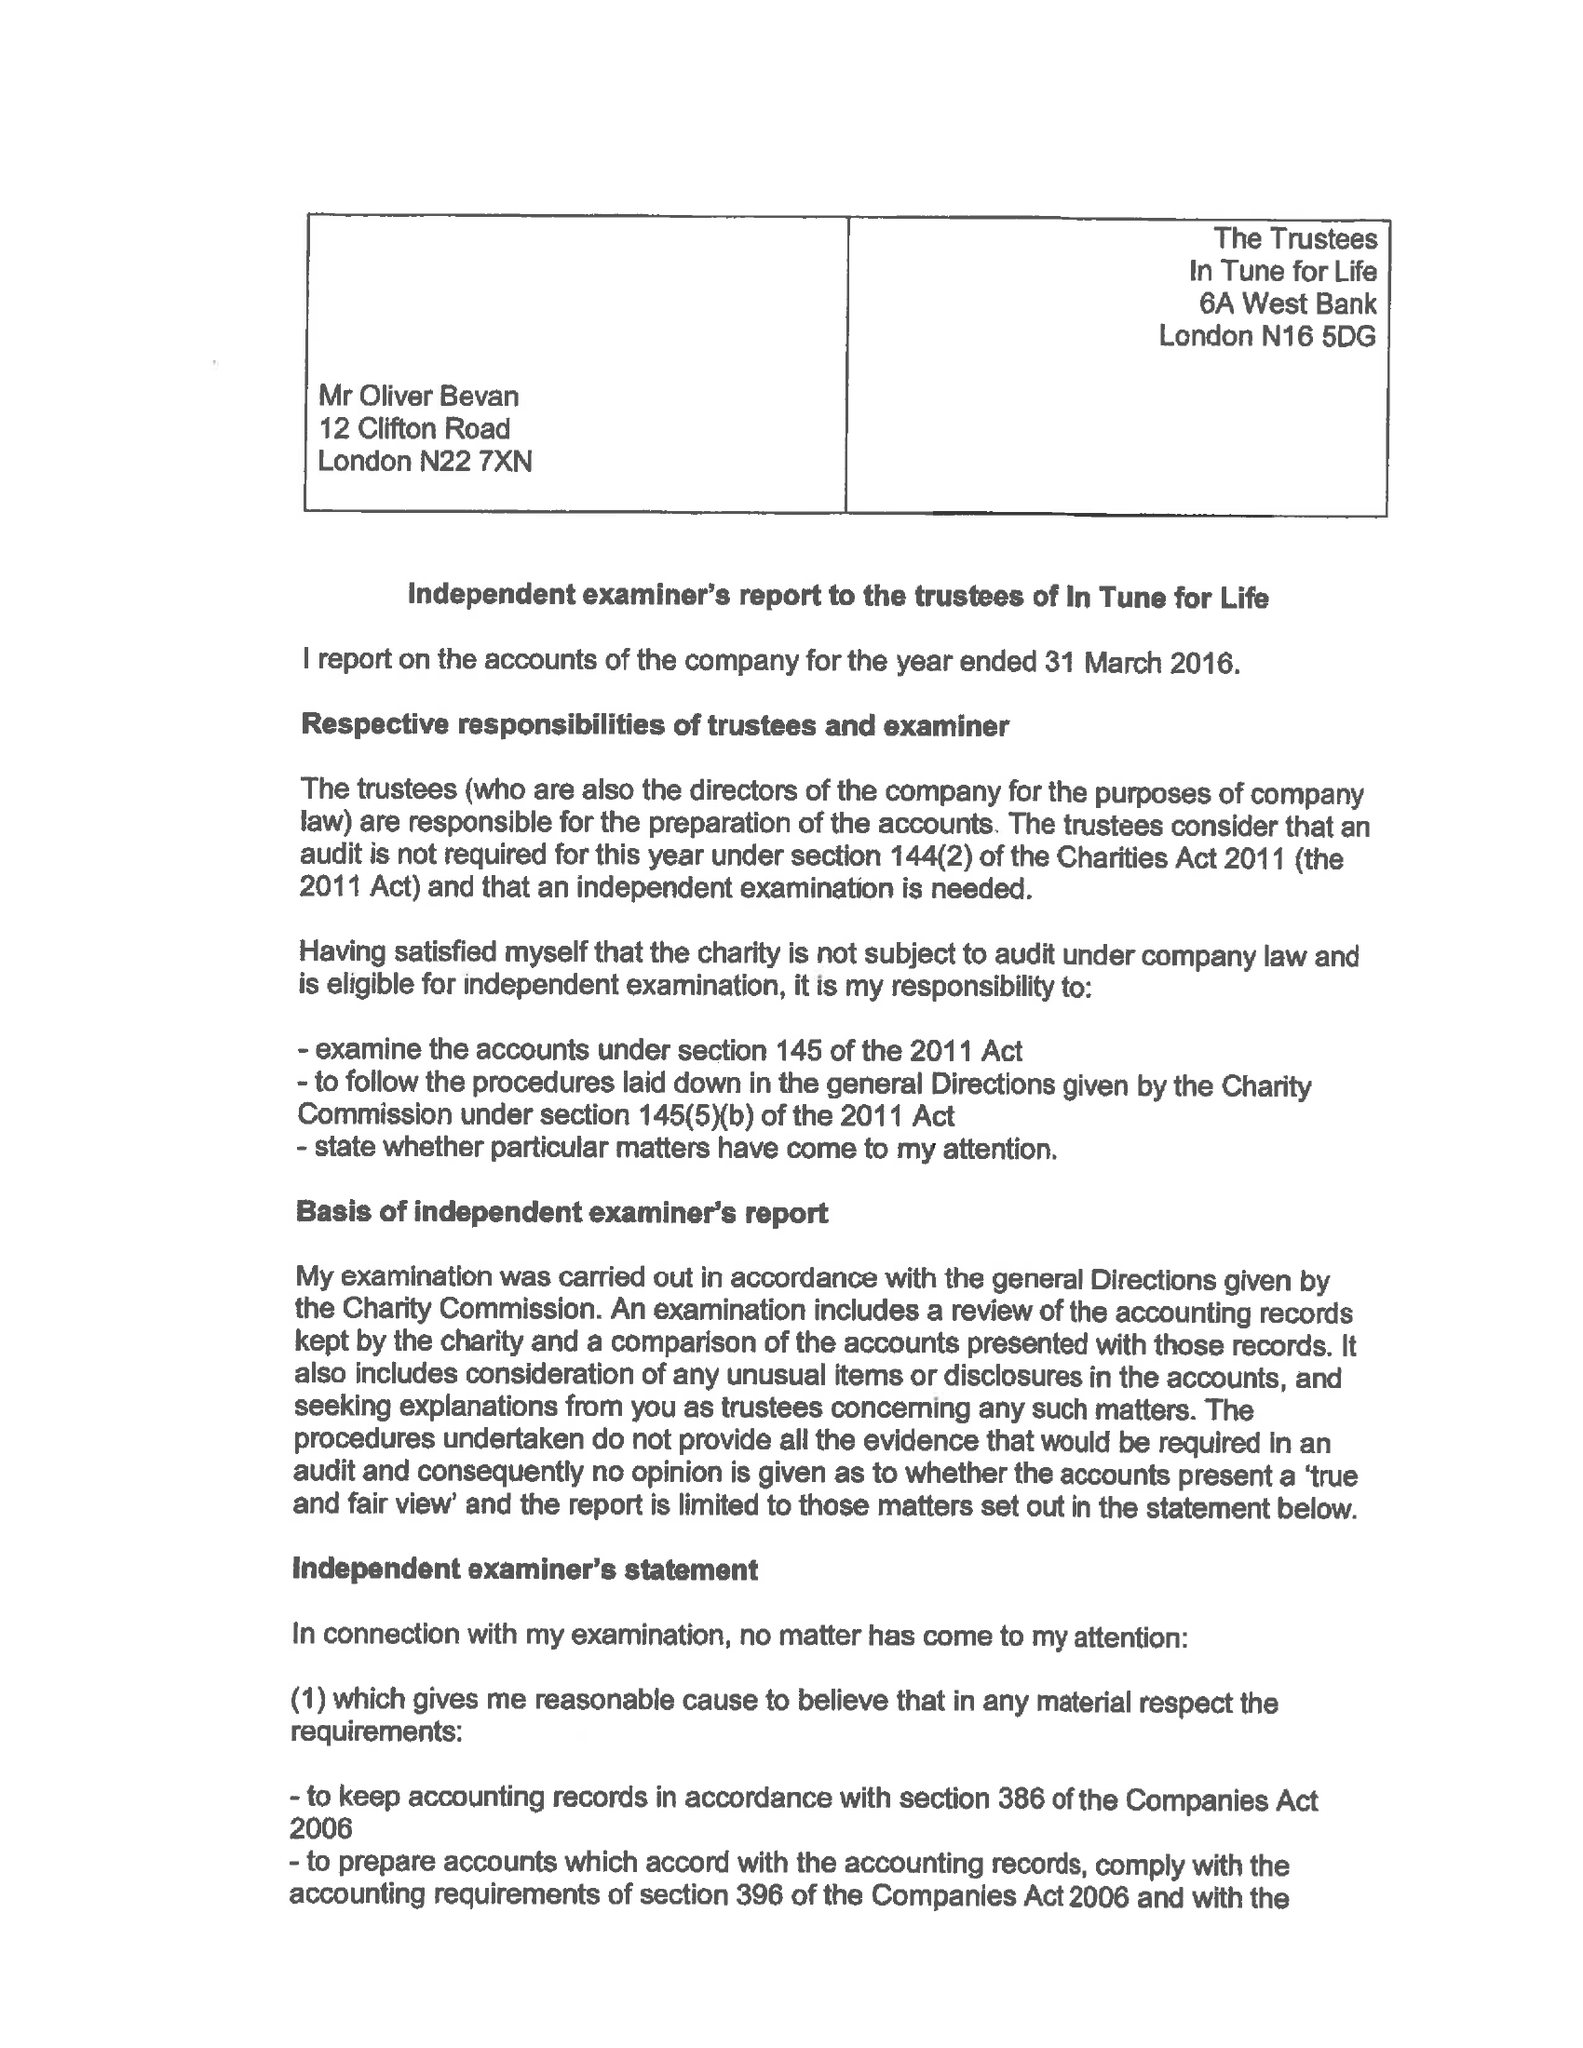What is the value for the address__post_town?
Answer the question using a single word or phrase. WATERLOOVILLE 